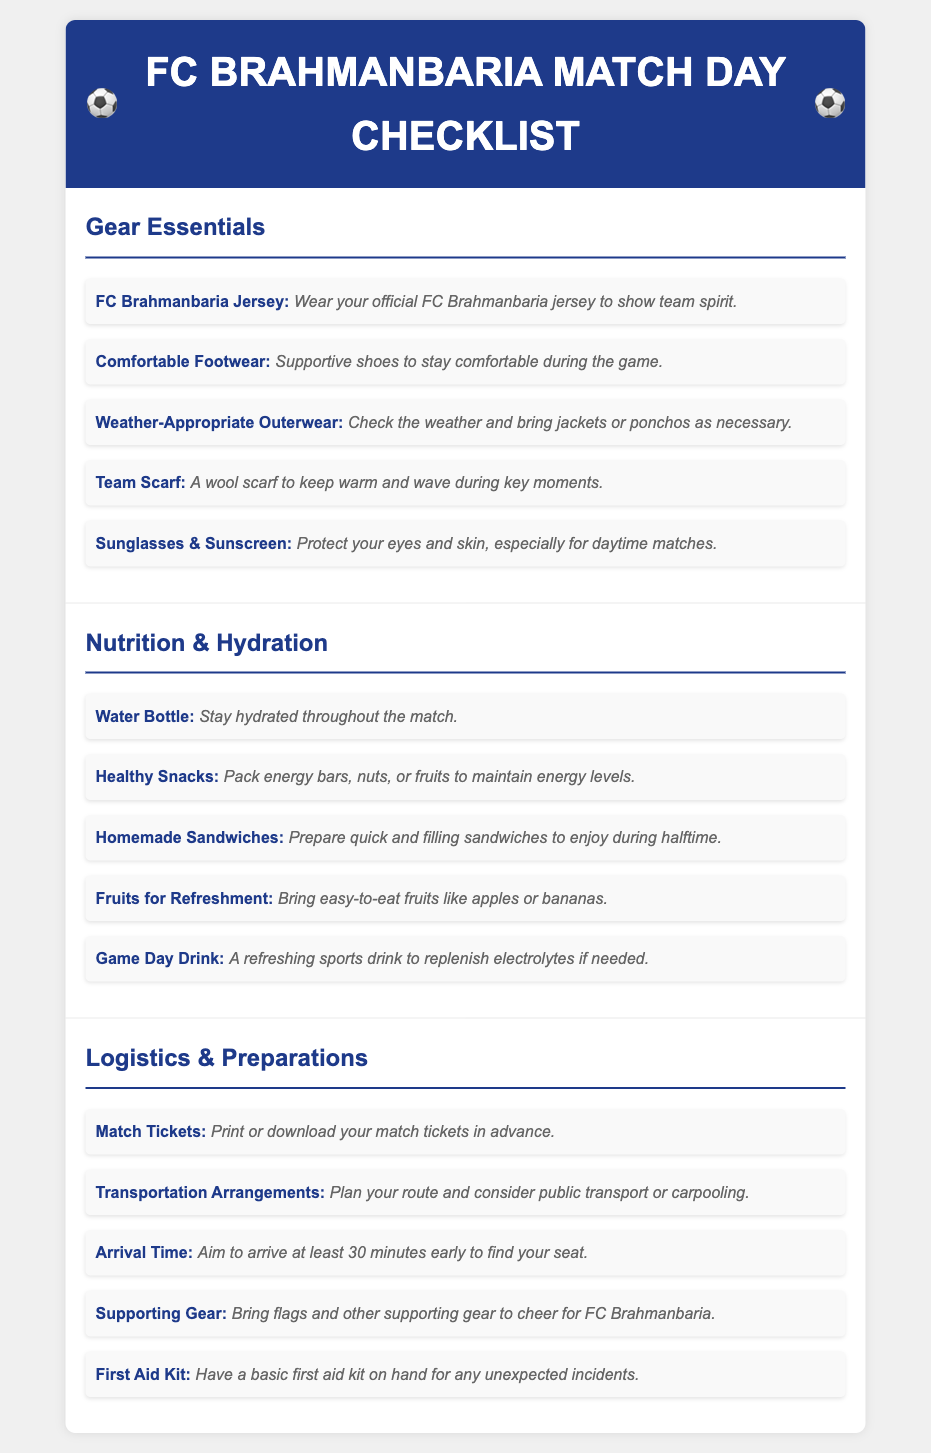What should you wear to show team spirit? The document suggests wearing the official FC Brahmanbaria jersey for team spirit.
Answer: FC Brahmanbaria jersey What type of footwear is recommended? The checklist recommends comfortable and supportive shoes for the game.
Answer: Comfortable Footwear What is one healthy snack to bring? The document mentions packing energy bars, nuts, or fruits as healthy snacks.
Answer: Energy bars How many minutes early should you arrive? The document states that you should aim to arrive at least 30 minutes early.
Answer: 30 minutes What is an important item for hydration? A water bottle is listed as essential for staying hydrated during the match.
Answer: Water Bottle What item is suggested for sun protection? The checklist suggests bringing sunglasses and sunscreen for sun protection.
Answer: Sunglasses & Sunscreen What should you prepare for halftime? The document advises preparing homemade sandwiches for halftime.
Answer: Homemade Sandwiches What should you bring to cheer for the team? The checklist recommends bringing flags and other supporting gear to cheer.
Answer: Supporting Gear What should you have on hand for unexpected incidents? The document mentions having a basic first aid kit ready for unexpected incidents.
Answer: First Aid Kit 